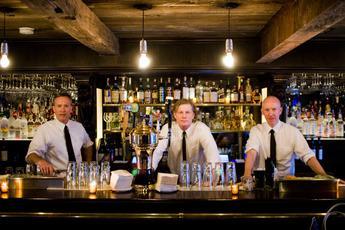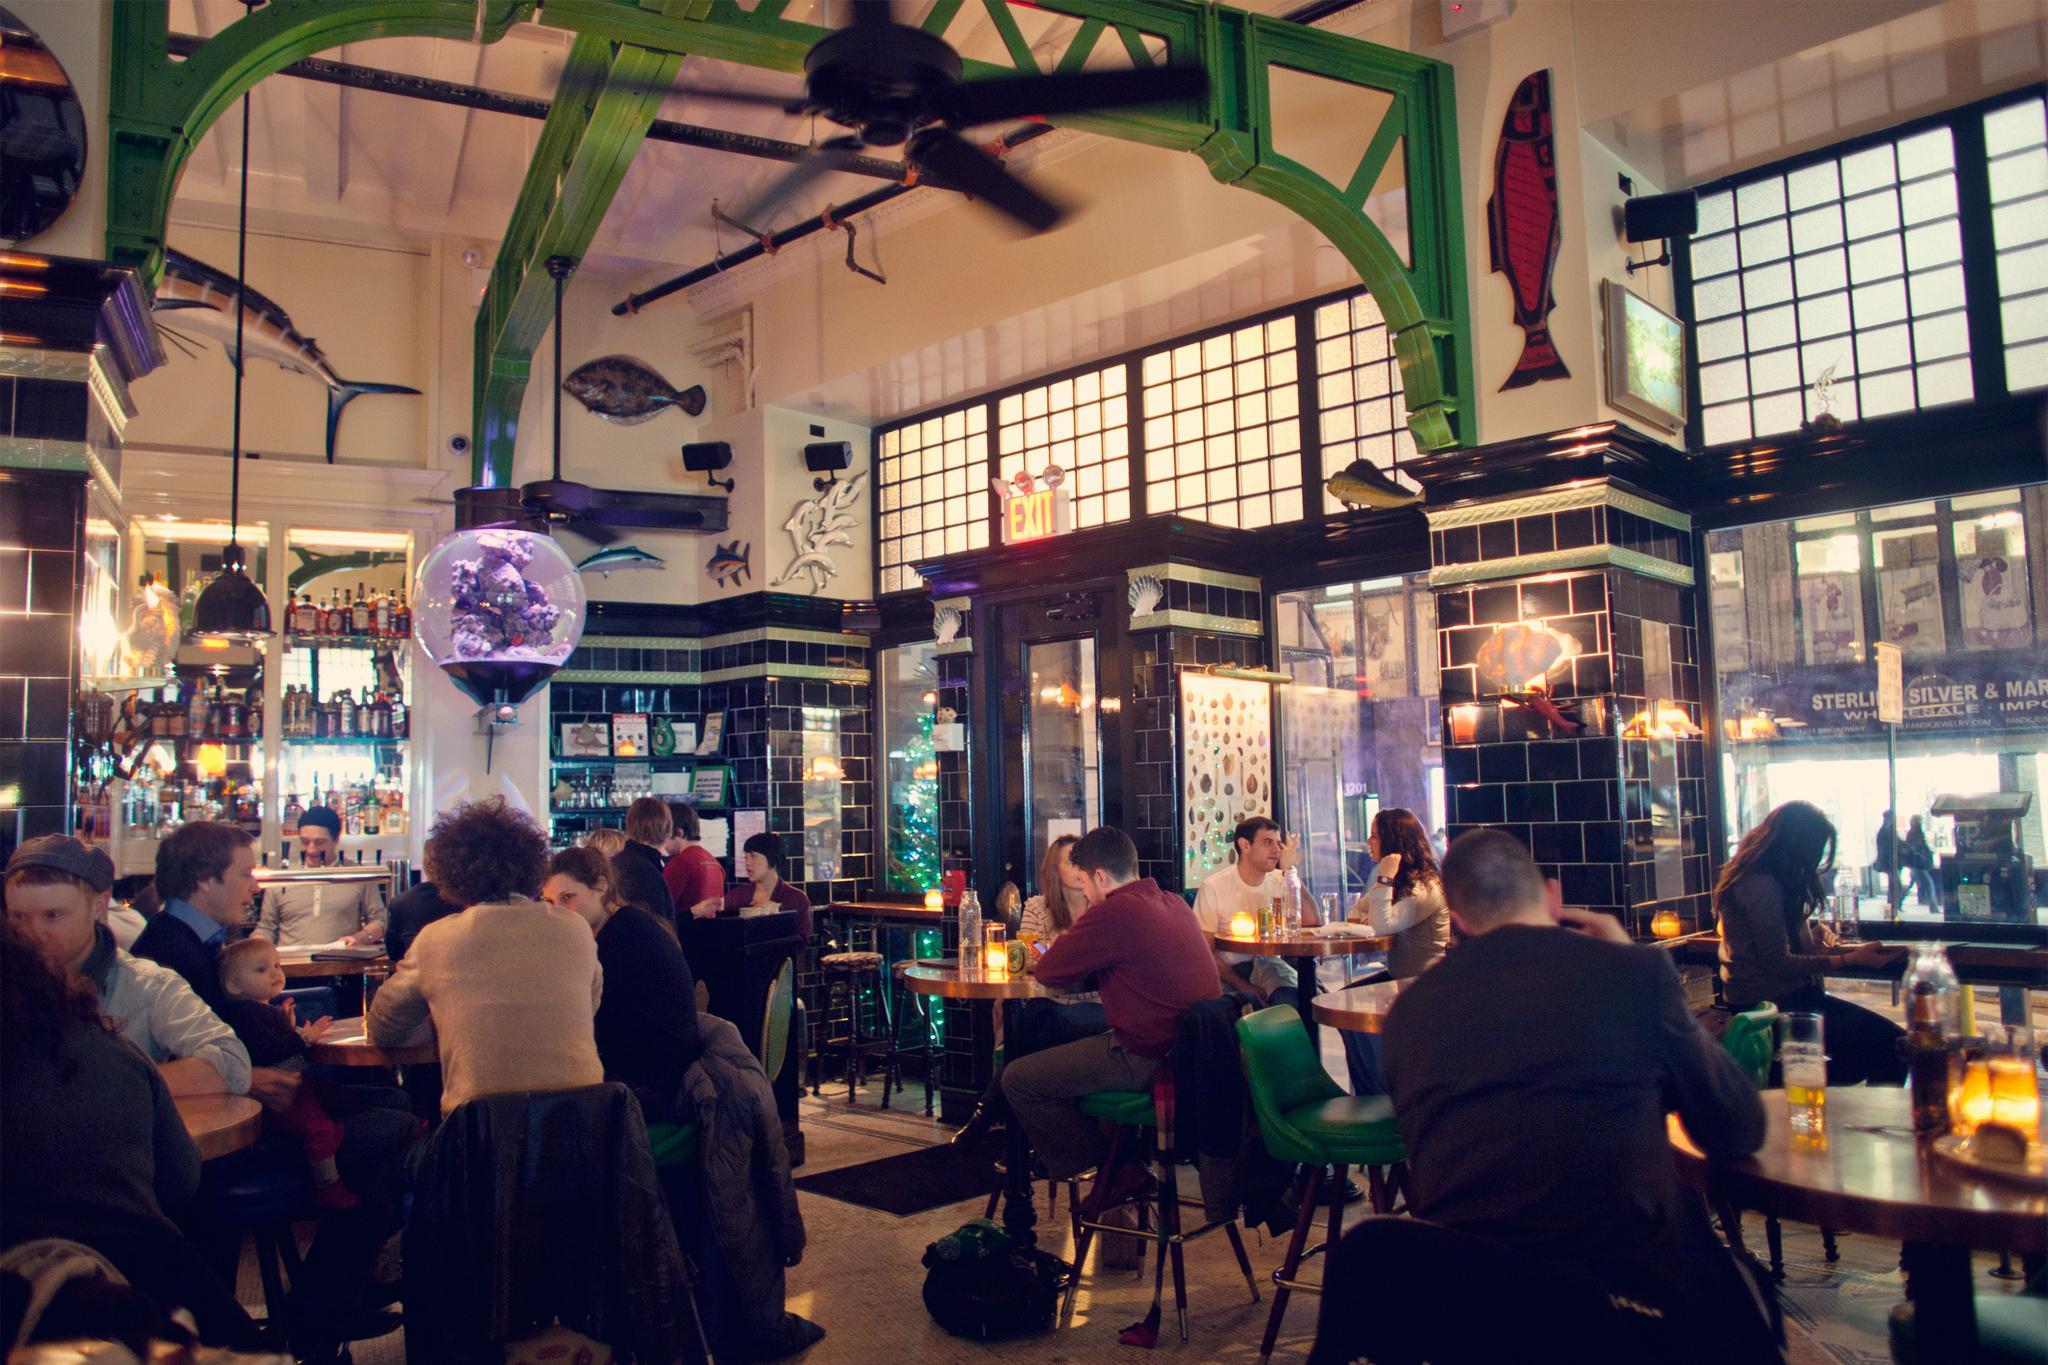The first image is the image on the left, the second image is the image on the right. For the images shown, is this caption "In one image, shelves of bottles are behind multiple bartenders in white shirts with neckties, who stand in front of a bar counter." true? Answer yes or no. Yes. 